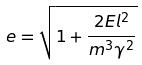<formula> <loc_0><loc_0><loc_500><loc_500>e = \sqrt { 1 + \frac { 2 E l ^ { 2 } } { m ^ { 3 } \gamma ^ { 2 } } }</formula> 